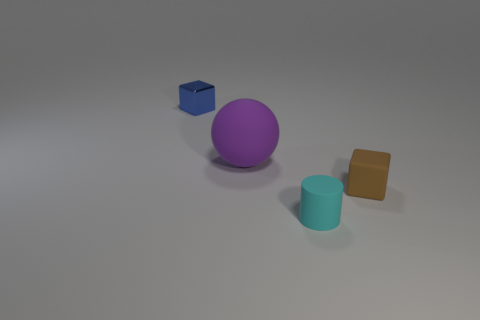Are there any other things that are the same material as the small blue cube?
Make the answer very short. No. Is there anything else that is the same size as the purple rubber object?
Offer a terse response. No. There is a block that is the same size as the brown rubber object; what is it made of?
Give a very brief answer. Metal. What is the shape of the blue object that is behind the small cube that is in front of the rubber object that is behind the brown thing?
Your answer should be compact. Cube. What is the shape of the brown rubber thing that is the same size as the blue metallic block?
Provide a succinct answer. Cube. There is a rubber object that is left of the small cyan rubber thing on the right side of the large purple ball; how many small things are behind it?
Your answer should be compact. 1. Are there more small things on the left side of the small cyan cylinder than blue shiny things that are behind the shiny block?
Your answer should be very brief. Yes. What number of cyan rubber things are the same shape as the purple thing?
Your answer should be very brief. 0. What number of objects are blocks to the right of the blue metallic object or cubes that are in front of the big purple ball?
Offer a terse response. 1. What is the small thing that is left of the small rubber object that is on the left side of the tiny object on the right side of the tiny matte cylinder made of?
Give a very brief answer. Metal. 